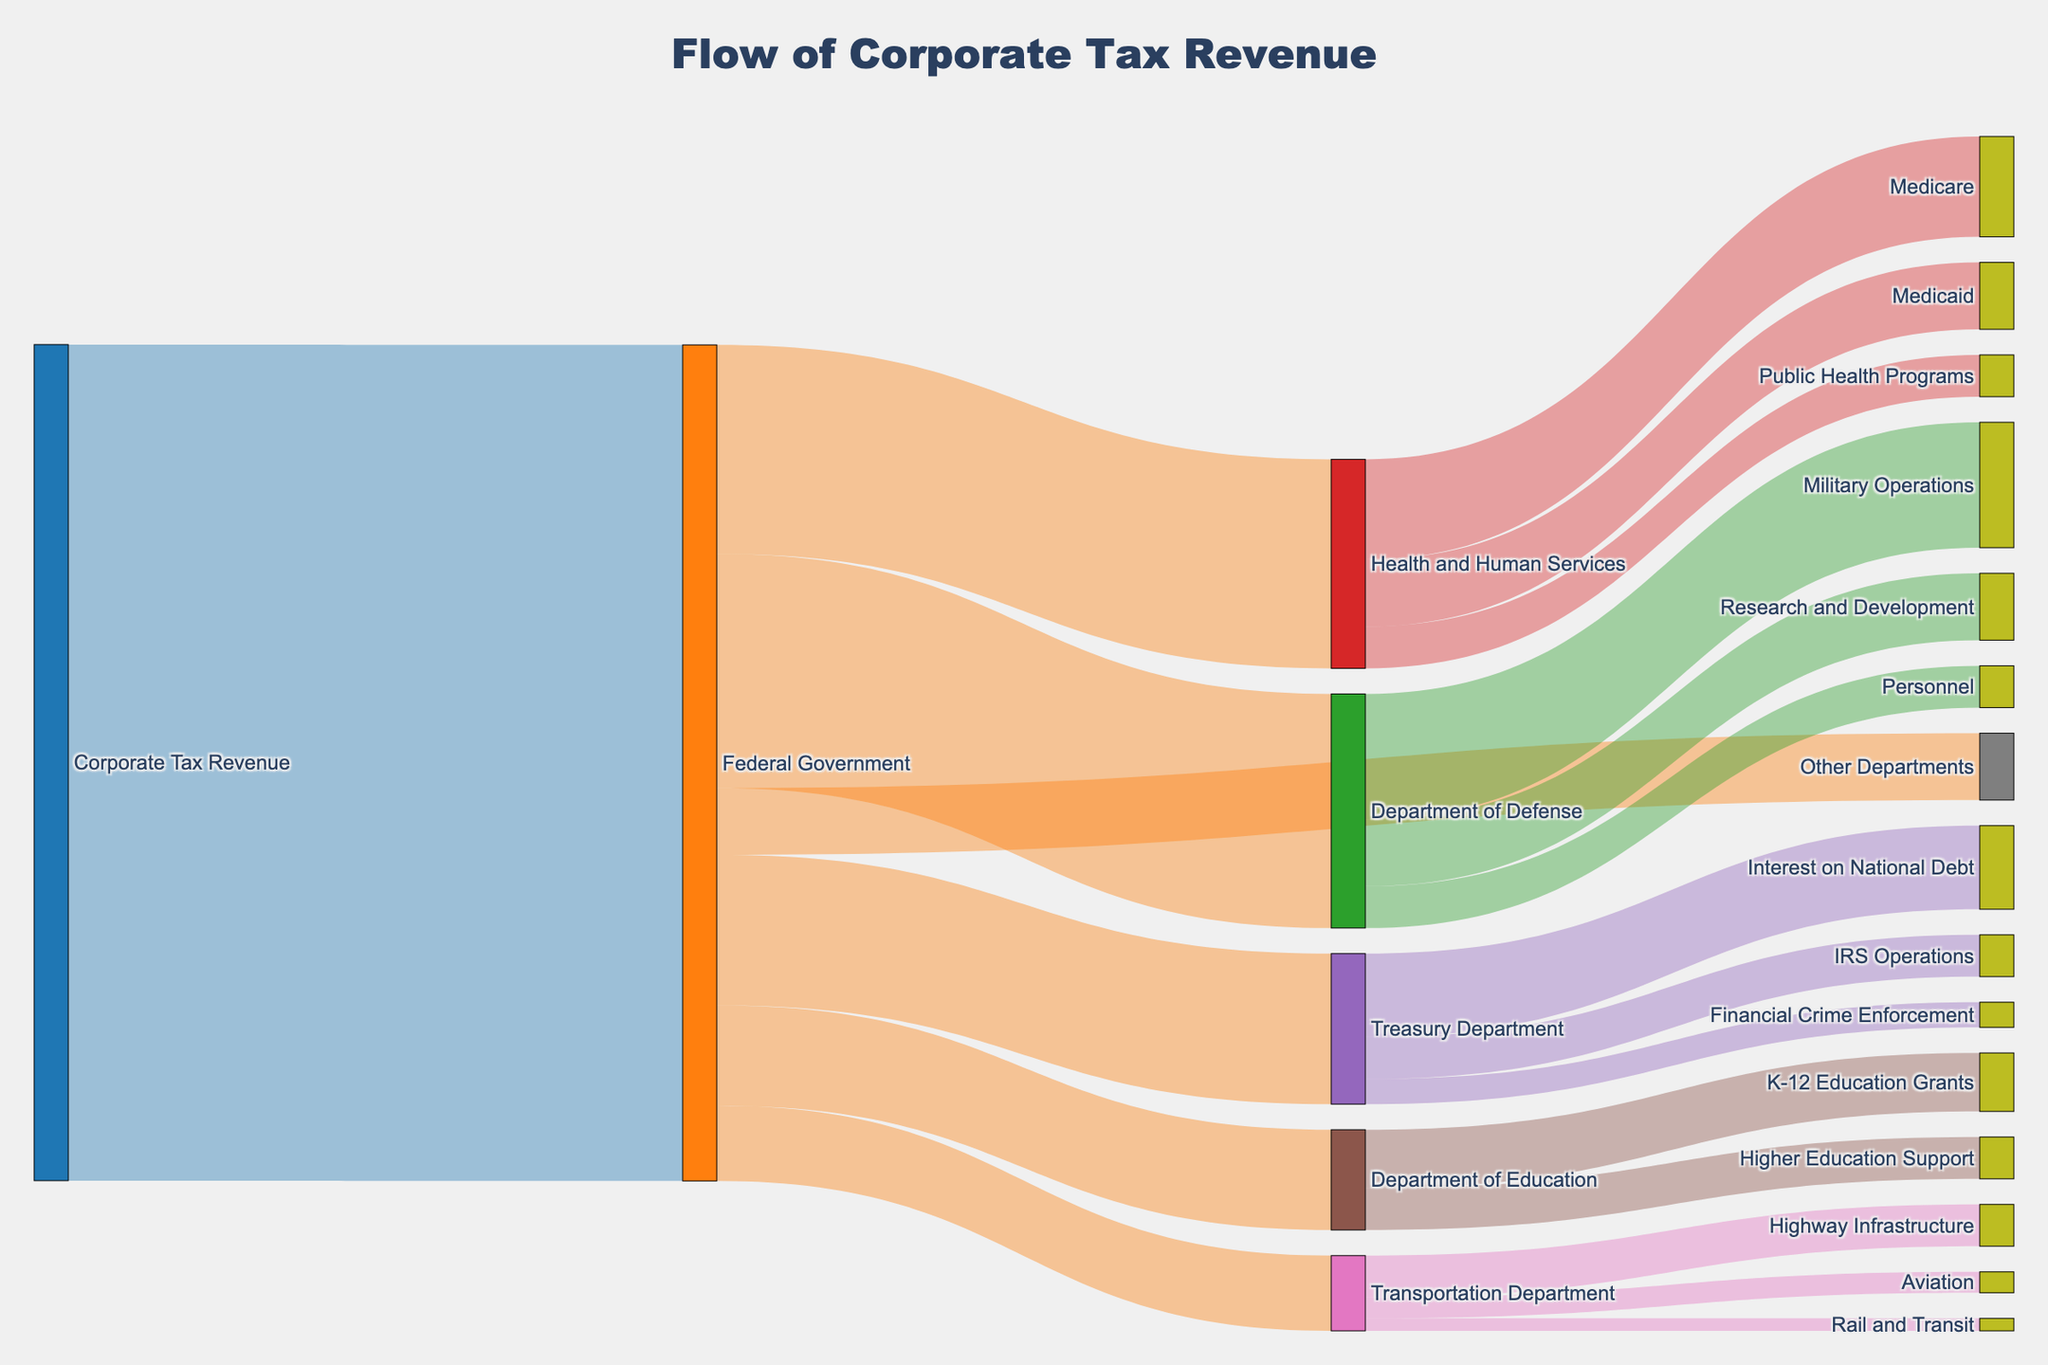What are the main departments and programs that receive corporate tax revenue from the Federal Government? By examining the figure, we can see the different nodes and the connections flowing from the Federal Government node. The main departments that receive corporate tax revenue are the Department of Defense, Health and Human Services, Treasury Department, Department of Education, Transportation Department, and Other Departments.
Answer: Department of Defense, Health and Human Services, Treasury Department, Department of Education, Transportation Department, Other Departments Which department receives the highest allocation from the Federal Government? We need to compare the values of the flows from the Federal Government node to each department. The Department of Defense receives the highest allocation with a value of 280.
Answer: Department of Defense What are the different programs under the Department of Defense, and what is the allocation for each? By looking at the nodes connected to the Department of Defense, we see the programs Military Operations, Research and Development, and Personnel. The allocations are 150, 80, and 50 respectively.
Answer: Military Operations (150), Research and Development (80), Personnel (50) How much corporate tax revenue is allocated to the Department of Education for K-12 Education Grants and Higher Education Support combined? We need to sum the values of the flows to K-12 Education Grants and Higher Education Support. The allocation to K-12 Education Grants is 70, and to Higher Education Support is 50. Summing these gives 70 + 50 = 120.
Answer: 120 Which program receives the least allocation from the Transportation Department, and what is the value? To find the program with the least allocation, we compare the values from the Transportation Department node to its connected programs. The program Rail and Transit receives the least allocation with a value of 15.
Answer: Rail and Transit (15) Compare the allocation to Medicare and Military Operations. Which one receives more funding? We need to compare the values of the flows to these two nodes. The allocation to Medicare is 120, while Military Operations receives 150. Thus, Military Operations receives more funding.
Answer: Military Operations What proportion of the Treasury Department's allocation goes toward Interest on National Debt? The total allocation to the Treasury Department is the sum of funds for Interest on National Debt, IRS Operations, and Financial Crime Enforcement, which are 100, 50, and 30 respectively. The total is 100 + 50 + 30 = 180. The proportion for Interest on National Debt is 100/180 = 5/9, which is approximately 0.556 or 55.6%.
Answer: 55.6% How is the Federal Government's total revenue distributed among the main departments? By looking at the direct flows from the Federal Government node, we can sum up the values to each department: 
Department of Defense (280), 
Health and Human Services (250), 
Treasury Department (180), 
Department of Education (120), 
Transportation Department (90), 
Other Departments (80). 
These should sum to 280 + 250 + 180 + 120 + 90 + 80 = 1000.
Answer: 280 to Defense, 250 to Health, 180 to Treasury, 120 to Education, 90 to Transportation, 80 to Others 